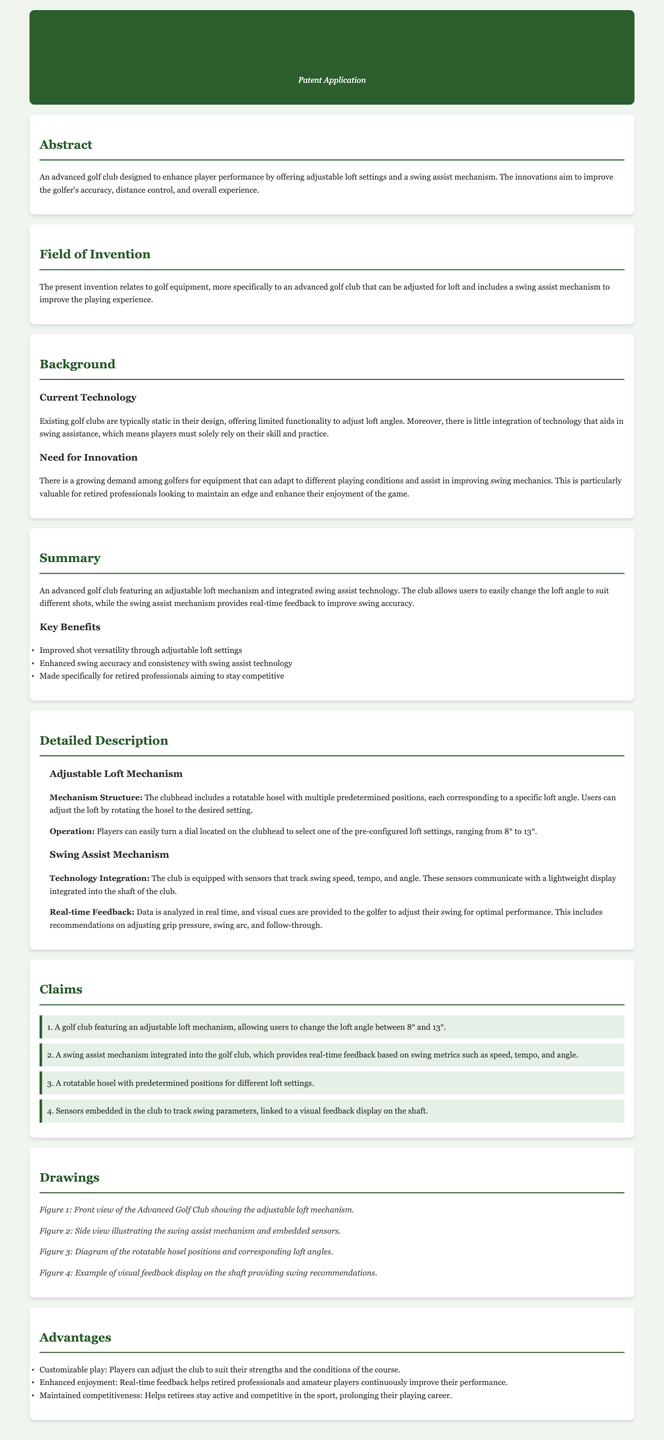What is the title of the patent application? The title of the patent application is explicitly stated at the top of the document.
Answer: Advanced Golf Club with Adjustable Loft and Swing Assist Mechanism What is the range of loft angles that can be adjusted? The document specifies the loft angle range in the detailed description section.
Answer: 8° to 13° What technology is integrated into the golf club? The document mentions the specific technology aimed at assisting golfers in their performance.
Answer: Swing assist mechanism Who is the target audience for this golf club? The document indicates a specific group of players who would benefit from the invention in its summary.
Answer: Retired professionals How many claims are presented in the patent application? The total number of claims is listed under the claims section of the document.
Answer: 4 What type of feedback does the swing assist mechanism provide? The document explains the nature of the feedback provided to golfers during their swing.
Answer: Real-time feedback What are the key benefits of the advanced golf club? The key benefits are specifically outlined in a bulleted list in the summary section.
Answer: Improved shot versatility, enhanced swing accuracy, made specifically for retired professionals What are the two main components described in the detailed description? The document outlines the two primary mechanisms within the detailed description section.
Answer: Adjustable loft mechanism and swing assist mechanism 